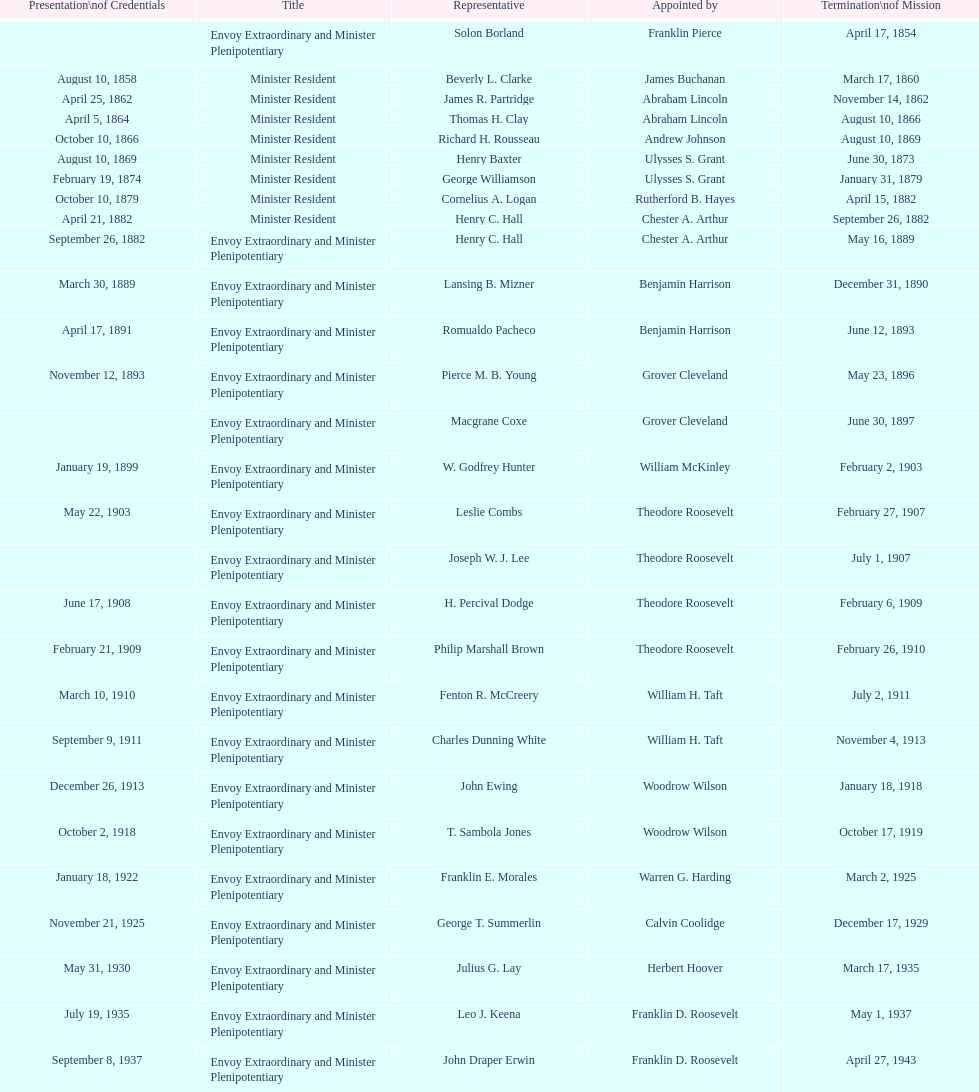Who was the last representative picked? Lisa Kubiske. 